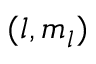<formula> <loc_0><loc_0><loc_500><loc_500>( l , m _ { l } )</formula> 